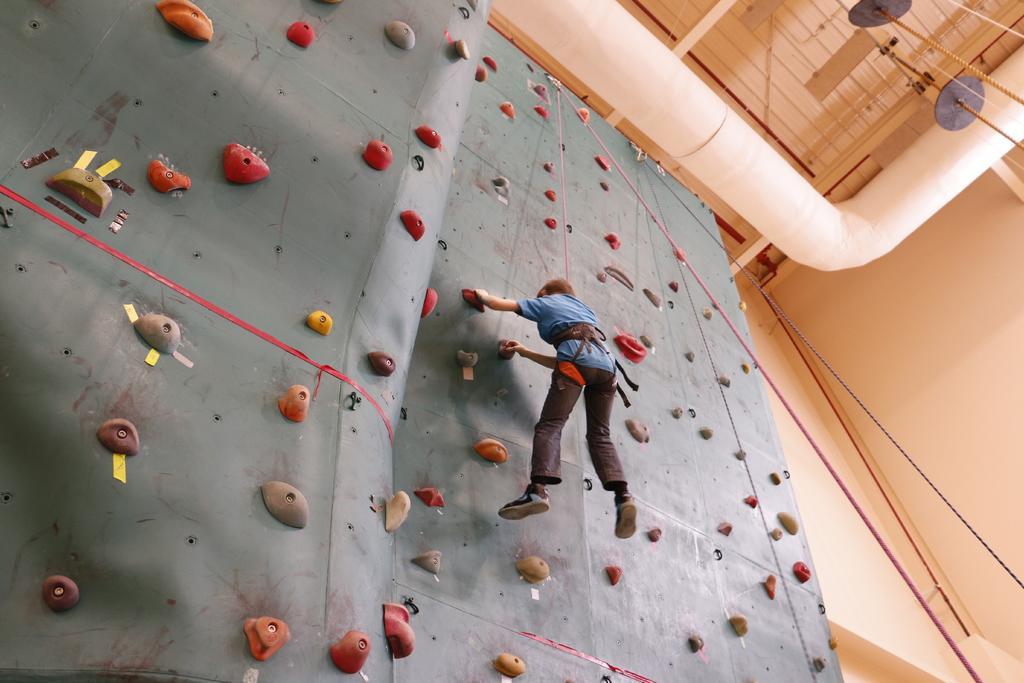Please provide a concise description of this image. In the center of the image there is a climbing wall and we can see a person in the center. In the background there is a wall. At the top there are pipes and ropes. 